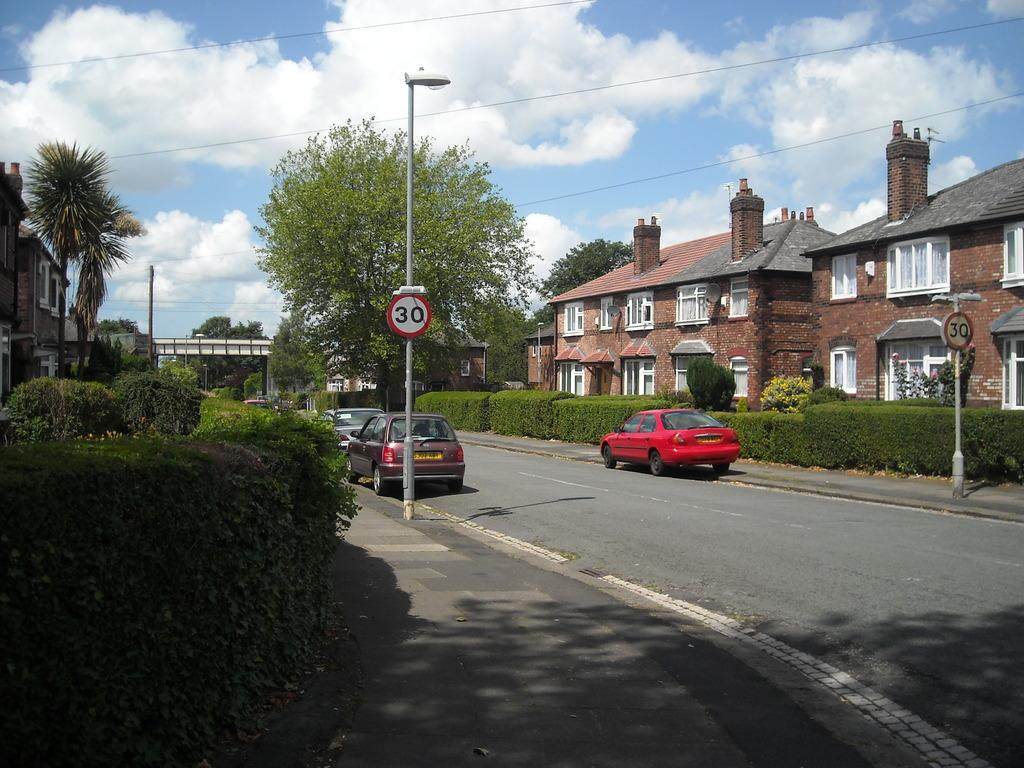What type of structures can be seen in the image? There are buildings in the image. What natural elements are present in the image? There are trees and plants in the image. What man-made objects can be seen in the image? There are poles with lights and boards, as well as wires in the image. What is visible in the background of the image? The sky is visible in the background of the image, with clouds present. What type of journey is depicted in the image? There is no journey depicted in the image; it features buildings, trees, plants, poles with lights and boards, wires, and a sky with clouds. What type of tank is visible in the image? There is no tank present in the image. 